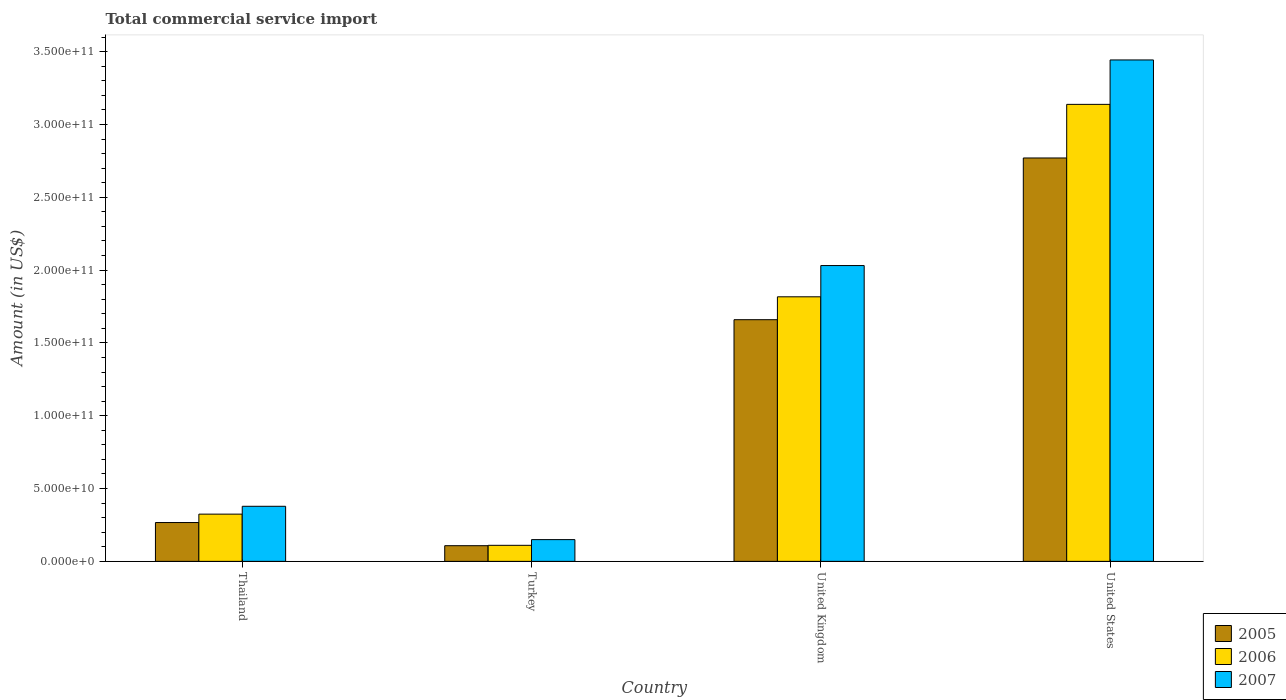How many groups of bars are there?
Ensure brevity in your answer.  4. Are the number of bars on each tick of the X-axis equal?
Your answer should be very brief. Yes. What is the label of the 3rd group of bars from the left?
Give a very brief answer. United Kingdom. In how many cases, is the number of bars for a given country not equal to the number of legend labels?
Make the answer very short. 0. What is the total commercial service import in 2007 in United Kingdom?
Your answer should be compact. 2.03e+11. Across all countries, what is the maximum total commercial service import in 2005?
Your answer should be very brief. 2.77e+11. Across all countries, what is the minimum total commercial service import in 2006?
Provide a short and direct response. 1.10e+1. In which country was the total commercial service import in 2006 maximum?
Give a very brief answer. United States. In which country was the total commercial service import in 2007 minimum?
Provide a succinct answer. Turkey. What is the total total commercial service import in 2005 in the graph?
Offer a terse response. 4.80e+11. What is the difference between the total commercial service import in 2005 in United Kingdom and that in United States?
Make the answer very short. -1.11e+11. What is the difference between the total commercial service import in 2005 in United Kingdom and the total commercial service import in 2007 in United States?
Provide a short and direct response. -1.78e+11. What is the average total commercial service import in 2006 per country?
Your answer should be compact. 1.35e+11. What is the difference between the total commercial service import of/in 2006 and total commercial service import of/in 2007 in Thailand?
Ensure brevity in your answer.  -5.38e+09. In how many countries, is the total commercial service import in 2006 greater than 200000000000 US$?
Make the answer very short. 1. What is the ratio of the total commercial service import in 2005 in Thailand to that in United States?
Your response must be concise. 0.1. Is the difference between the total commercial service import in 2006 in Thailand and United Kingdom greater than the difference between the total commercial service import in 2007 in Thailand and United Kingdom?
Give a very brief answer. Yes. What is the difference between the highest and the second highest total commercial service import in 2007?
Make the answer very short. 3.06e+11. What is the difference between the highest and the lowest total commercial service import in 2006?
Provide a succinct answer. 3.03e+11. In how many countries, is the total commercial service import in 2007 greater than the average total commercial service import in 2007 taken over all countries?
Provide a succinct answer. 2. Is the sum of the total commercial service import in 2007 in Turkey and United States greater than the maximum total commercial service import in 2006 across all countries?
Give a very brief answer. Yes. What does the 2nd bar from the left in United Kingdom represents?
Your answer should be very brief. 2006. What does the 2nd bar from the right in United States represents?
Ensure brevity in your answer.  2006. Is it the case that in every country, the sum of the total commercial service import in 2006 and total commercial service import in 2007 is greater than the total commercial service import in 2005?
Your answer should be very brief. Yes. How many bars are there?
Make the answer very short. 12. How many countries are there in the graph?
Ensure brevity in your answer.  4. What is the difference between two consecutive major ticks on the Y-axis?
Your response must be concise. 5.00e+1. Where does the legend appear in the graph?
Provide a short and direct response. Bottom right. What is the title of the graph?
Provide a short and direct response. Total commercial service import. Does "1995" appear as one of the legend labels in the graph?
Keep it short and to the point. No. What is the label or title of the Y-axis?
Keep it short and to the point. Amount (in US$). What is the Amount (in US$) in 2005 in Thailand?
Ensure brevity in your answer.  2.67e+1. What is the Amount (in US$) in 2006 in Thailand?
Offer a terse response. 3.24e+1. What is the Amount (in US$) of 2007 in Thailand?
Your answer should be very brief. 3.78e+1. What is the Amount (in US$) of 2005 in Turkey?
Your answer should be compact. 1.08e+1. What is the Amount (in US$) of 2006 in Turkey?
Your answer should be compact. 1.10e+1. What is the Amount (in US$) in 2007 in Turkey?
Your answer should be very brief. 1.49e+1. What is the Amount (in US$) of 2005 in United Kingdom?
Ensure brevity in your answer.  1.66e+11. What is the Amount (in US$) of 2006 in United Kingdom?
Your answer should be compact. 1.82e+11. What is the Amount (in US$) of 2007 in United Kingdom?
Your response must be concise. 2.03e+11. What is the Amount (in US$) in 2005 in United States?
Provide a short and direct response. 2.77e+11. What is the Amount (in US$) of 2006 in United States?
Offer a terse response. 3.14e+11. What is the Amount (in US$) of 2007 in United States?
Provide a succinct answer. 3.44e+11. Across all countries, what is the maximum Amount (in US$) in 2005?
Provide a succinct answer. 2.77e+11. Across all countries, what is the maximum Amount (in US$) in 2006?
Offer a very short reply. 3.14e+11. Across all countries, what is the maximum Amount (in US$) in 2007?
Ensure brevity in your answer.  3.44e+11. Across all countries, what is the minimum Amount (in US$) of 2005?
Your answer should be compact. 1.08e+1. Across all countries, what is the minimum Amount (in US$) of 2006?
Provide a short and direct response. 1.10e+1. Across all countries, what is the minimum Amount (in US$) in 2007?
Offer a very short reply. 1.49e+1. What is the total Amount (in US$) in 2005 in the graph?
Offer a terse response. 4.80e+11. What is the total Amount (in US$) in 2006 in the graph?
Offer a terse response. 5.39e+11. What is the total Amount (in US$) in 2007 in the graph?
Provide a succinct answer. 6.00e+11. What is the difference between the Amount (in US$) in 2005 in Thailand and that in Turkey?
Ensure brevity in your answer.  1.59e+1. What is the difference between the Amount (in US$) in 2006 in Thailand and that in Turkey?
Your answer should be very brief. 2.14e+1. What is the difference between the Amount (in US$) in 2007 in Thailand and that in Turkey?
Provide a succinct answer. 2.29e+1. What is the difference between the Amount (in US$) in 2005 in Thailand and that in United Kingdom?
Your answer should be very brief. -1.39e+11. What is the difference between the Amount (in US$) in 2006 in Thailand and that in United Kingdom?
Provide a short and direct response. -1.49e+11. What is the difference between the Amount (in US$) of 2007 in Thailand and that in United Kingdom?
Your response must be concise. -1.65e+11. What is the difference between the Amount (in US$) in 2005 in Thailand and that in United States?
Keep it short and to the point. -2.50e+11. What is the difference between the Amount (in US$) of 2006 in Thailand and that in United States?
Your answer should be compact. -2.81e+11. What is the difference between the Amount (in US$) in 2007 in Thailand and that in United States?
Provide a short and direct response. -3.06e+11. What is the difference between the Amount (in US$) of 2005 in Turkey and that in United Kingdom?
Offer a very short reply. -1.55e+11. What is the difference between the Amount (in US$) of 2006 in Turkey and that in United Kingdom?
Offer a terse response. -1.71e+11. What is the difference between the Amount (in US$) in 2007 in Turkey and that in United Kingdom?
Keep it short and to the point. -1.88e+11. What is the difference between the Amount (in US$) in 2005 in Turkey and that in United States?
Offer a very short reply. -2.66e+11. What is the difference between the Amount (in US$) of 2006 in Turkey and that in United States?
Your response must be concise. -3.03e+11. What is the difference between the Amount (in US$) in 2007 in Turkey and that in United States?
Your answer should be very brief. -3.29e+11. What is the difference between the Amount (in US$) of 2005 in United Kingdom and that in United States?
Provide a succinct answer. -1.11e+11. What is the difference between the Amount (in US$) of 2006 in United Kingdom and that in United States?
Give a very brief answer. -1.32e+11. What is the difference between the Amount (in US$) of 2007 in United Kingdom and that in United States?
Offer a very short reply. -1.41e+11. What is the difference between the Amount (in US$) of 2005 in Thailand and the Amount (in US$) of 2006 in Turkey?
Your response must be concise. 1.56e+1. What is the difference between the Amount (in US$) in 2005 in Thailand and the Amount (in US$) in 2007 in Turkey?
Keep it short and to the point. 1.17e+1. What is the difference between the Amount (in US$) in 2006 in Thailand and the Amount (in US$) in 2007 in Turkey?
Offer a very short reply. 1.75e+1. What is the difference between the Amount (in US$) of 2005 in Thailand and the Amount (in US$) of 2006 in United Kingdom?
Provide a succinct answer. -1.55e+11. What is the difference between the Amount (in US$) in 2005 in Thailand and the Amount (in US$) in 2007 in United Kingdom?
Provide a short and direct response. -1.76e+11. What is the difference between the Amount (in US$) in 2006 in Thailand and the Amount (in US$) in 2007 in United Kingdom?
Your answer should be very brief. -1.71e+11. What is the difference between the Amount (in US$) in 2005 in Thailand and the Amount (in US$) in 2006 in United States?
Ensure brevity in your answer.  -2.87e+11. What is the difference between the Amount (in US$) in 2005 in Thailand and the Amount (in US$) in 2007 in United States?
Offer a terse response. -3.18e+11. What is the difference between the Amount (in US$) of 2006 in Thailand and the Amount (in US$) of 2007 in United States?
Your answer should be compact. -3.12e+11. What is the difference between the Amount (in US$) in 2005 in Turkey and the Amount (in US$) in 2006 in United Kingdom?
Your response must be concise. -1.71e+11. What is the difference between the Amount (in US$) of 2005 in Turkey and the Amount (in US$) of 2007 in United Kingdom?
Offer a very short reply. -1.92e+11. What is the difference between the Amount (in US$) of 2006 in Turkey and the Amount (in US$) of 2007 in United Kingdom?
Make the answer very short. -1.92e+11. What is the difference between the Amount (in US$) of 2005 in Turkey and the Amount (in US$) of 2006 in United States?
Your answer should be compact. -3.03e+11. What is the difference between the Amount (in US$) of 2005 in Turkey and the Amount (in US$) of 2007 in United States?
Your answer should be very brief. -3.34e+11. What is the difference between the Amount (in US$) of 2006 in Turkey and the Amount (in US$) of 2007 in United States?
Provide a succinct answer. -3.33e+11. What is the difference between the Amount (in US$) in 2005 in United Kingdom and the Amount (in US$) in 2006 in United States?
Make the answer very short. -1.48e+11. What is the difference between the Amount (in US$) of 2005 in United Kingdom and the Amount (in US$) of 2007 in United States?
Offer a terse response. -1.78e+11. What is the difference between the Amount (in US$) of 2006 in United Kingdom and the Amount (in US$) of 2007 in United States?
Offer a very short reply. -1.63e+11. What is the average Amount (in US$) of 2005 per country?
Your answer should be compact. 1.20e+11. What is the average Amount (in US$) of 2006 per country?
Ensure brevity in your answer.  1.35e+11. What is the average Amount (in US$) of 2007 per country?
Your response must be concise. 1.50e+11. What is the difference between the Amount (in US$) in 2005 and Amount (in US$) in 2006 in Thailand?
Your response must be concise. -5.77e+09. What is the difference between the Amount (in US$) of 2005 and Amount (in US$) of 2007 in Thailand?
Your response must be concise. -1.12e+1. What is the difference between the Amount (in US$) of 2006 and Amount (in US$) of 2007 in Thailand?
Make the answer very short. -5.38e+09. What is the difference between the Amount (in US$) in 2005 and Amount (in US$) in 2006 in Turkey?
Your response must be concise. -2.61e+08. What is the difference between the Amount (in US$) of 2005 and Amount (in US$) of 2007 in Turkey?
Keep it short and to the point. -4.18e+09. What is the difference between the Amount (in US$) in 2006 and Amount (in US$) in 2007 in Turkey?
Provide a succinct answer. -3.92e+09. What is the difference between the Amount (in US$) of 2005 and Amount (in US$) of 2006 in United Kingdom?
Provide a short and direct response. -1.57e+1. What is the difference between the Amount (in US$) in 2005 and Amount (in US$) in 2007 in United Kingdom?
Give a very brief answer. -3.72e+1. What is the difference between the Amount (in US$) in 2006 and Amount (in US$) in 2007 in United Kingdom?
Provide a short and direct response. -2.15e+1. What is the difference between the Amount (in US$) of 2005 and Amount (in US$) of 2006 in United States?
Your answer should be compact. -3.68e+1. What is the difference between the Amount (in US$) of 2005 and Amount (in US$) of 2007 in United States?
Keep it short and to the point. -6.73e+1. What is the difference between the Amount (in US$) in 2006 and Amount (in US$) in 2007 in United States?
Your answer should be very brief. -3.05e+1. What is the ratio of the Amount (in US$) in 2005 in Thailand to that in Turkey?
Ensure brevity in your answer.  2.48. What is the ratio of the Amount (in US$) in 2006 in Thailand to that in Turkey?
Provide a short and direct response. 2.94. What is the ratio of the Amount (in US$) of 2007 in Thailand to that in Turkey?
Provide a succinct answer. 2.53. What is the ratio of the Amount (in US$) of 2005 in Thailand to that in United Kingdom?
Make the answer very short. 0.16. What is the ratio of the Amount (in US$) of 2006 in Thailand to that in United Kingdom?
Ensure brevity in your answer.  0.18. What is the ratio of the Amount (in US$) of 2007 in Thailand to that in United Kingdom?
Your answer should be compact. 0.19. What is the ratio of the Amount (in US$) in 2005 in Thailand to that in United States?
Offer a very short reply. 0.1. What is the ratio of the Amount (in US$) in 2006 in Thailand to that in United States?
Your answer should be very brief. 0.1. What is the ratio of the Amount (in US$) in 2007 in Thailand to that in United States?
Your answer should be very brief. 0.11. What is the ratio of the Amount (in US$) of 2005 in Turkey to that in United Kingdom?
Your answer should be very brief. 0.06. What is the ratio of the Amount (in US$) in 2006 in Turkey to that in United Kingdom?
Offer a terse response. 0.06. What is the ratio of the Amount (in US$) of 2007 in Turkey to that in United Kingdom?
Offer a very short reply. 0.07. What is the ratio of the Amount (in US$) of 2005 in Turkey to that in United States?
Offer a terse response. 0.04. What is the ratio of the Amount (in US$) of 2006 in Turkey to that in United States?
Provide a short and direct response. 0.04. What is the ratio of the Amount (in US$) of 2007 in Turkey to that in United States?
Your response must be concise. 0.04. What is the ratio of the Amount (in US$) in 2005 in United Kingdom to that in United States?
Offer a very short reply. 0.6. What is the ratio of the Amount (in US$) in 2006 in United Kingdom to that in United States?
Your answer should be compact. 0.58. What is the ratio of the Amount (in US$) of 2007 in United Kingdom to that in United States?
Ensure brevity in your answer.  0.59. What is the difference between the highest and the second highest Amount (in US$) of 2005?
Your answer should be very brief. 1.11e+11. What is the difference between the highest and the second highest Amount (in US$) in 2006?
Offer a very short reply. 1.32e+11. What is the difference between the highest and the second highest Amount (in US$) of 2007?
Make the answer very short. 1.41e+11. What is the difference between the highest and the lowest Amount (in US$) in 2005?
Provide a short and direct response. 2.66e+11. What is the difference between the highest and the lowest Amount (in US$) in 2006?
Your answer should be compact. 3.03e+11. What is the difference between the highest and the lowest Amount (in US$) of 2007?
Keep it short and to the point. 3.29e+11. 